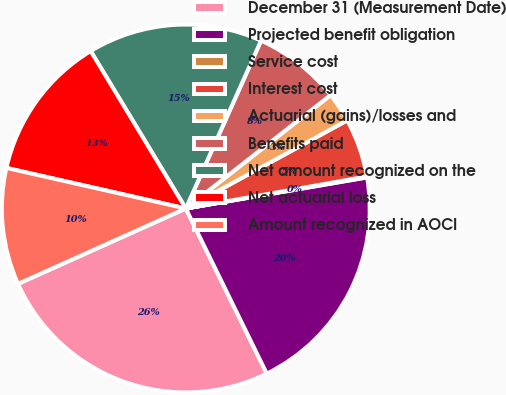Convert chart. <chart><loc_0><loc_0><loc_500><loc_500><pie_chart><fcel>December 31 (Measurement Date)<fcel>Projected benefit obligation<fcel>Service cost<fcel>Interest cost<fcel>Actuarial (gains)/losses and<fcel>Benefits paid<fcel>Net amount recognized on the<fcel>Net actuarial loss<fcel>Amount recognized in AOCI<nl><fcel>25.54%<fcel>20.45%<fcel>0.08%<fcel>5.17%<fcel>2.62%<fcel>7.72%<fcel>15.36%<fcel>12.81%<fcel>10.26%<nl></chart> 